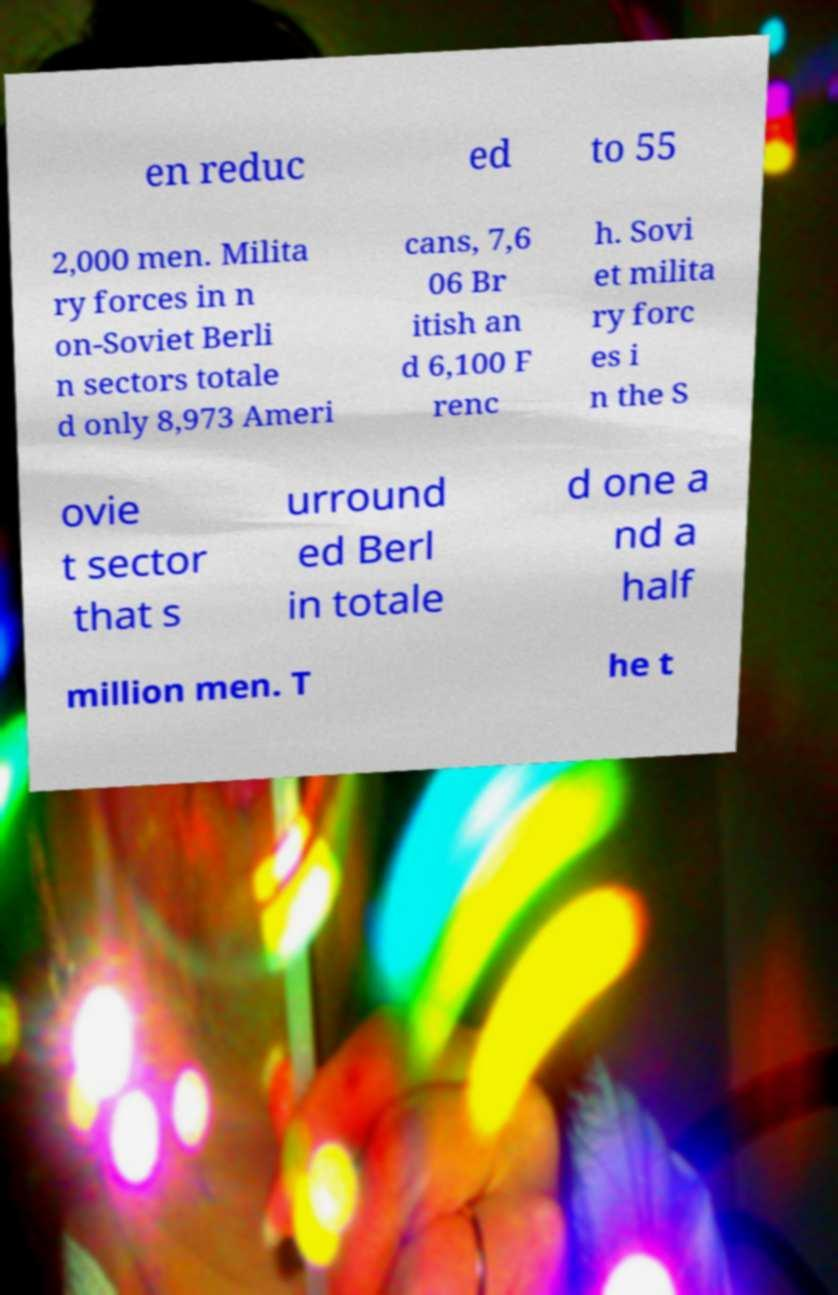Please read and relay the text visible in this image. What does it say? en reduc ed to 55 2,000 men. Milita ry forces in n on-Soviet Berli n sectors totale d only 8,973 Ameri cans, 7,6 06 Br itish an d 6,100 F renc h. Sovi et milita ry forc es i n the S ovie t sector that s urround ed Berl in totale d one a nd a half million men. T he t 